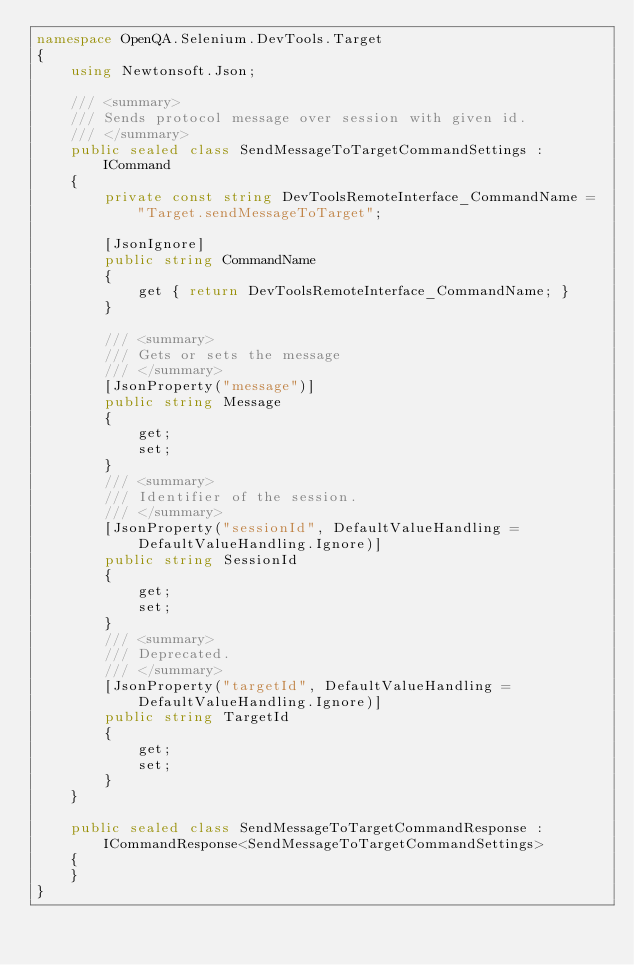Convert code to text. <code><loc_0><loc_0><loc_500><loc_500><_C#_>namespace OpenQA.Selenium.DevTools.Target
{
    using Newtonsoft.Json;

    /// <summary>
    /// Sends protocol message over session with given id.
    /// </summary>
    public sealed class SendMessageToTargetCommandSettings : ICommand
    {
        private const string DevToolsRemoteInterface_CommandName = "Target.sendMessageToTarget";
        
        [JsonIgnore]
        public string CommandName
        {
            get { return DevToolsRemoteInterface_CommandName; }
        }

        /// <summary>
        /// Gets or sets the message
        /// </summary>
        [JsonProperty("message")]
        public string Message
        {
            get;
            set;
        }
        /// <summary>
        /// Identifier of the session.
        /// </summary>
        [JsonProperty("sessionId", DefaultValueHandling = DefaultValueHandling.Ignore)]
        public string SessionId
        {
            get;
            set;
        }
        /// <summary>
        /// Deprecated.
        /// </summary>
        [JsonProperty("targetId", DefaultValueHandling = DefaultValueHandling.Ignore)]
        public string TargetId
        {
            get;
            set;
        }
    }

    public sealed class SendMessageToTargetCommandResponse : ICommandResponse<SendMessageToTargetCommandSettings>
    {
    }
}</code> 